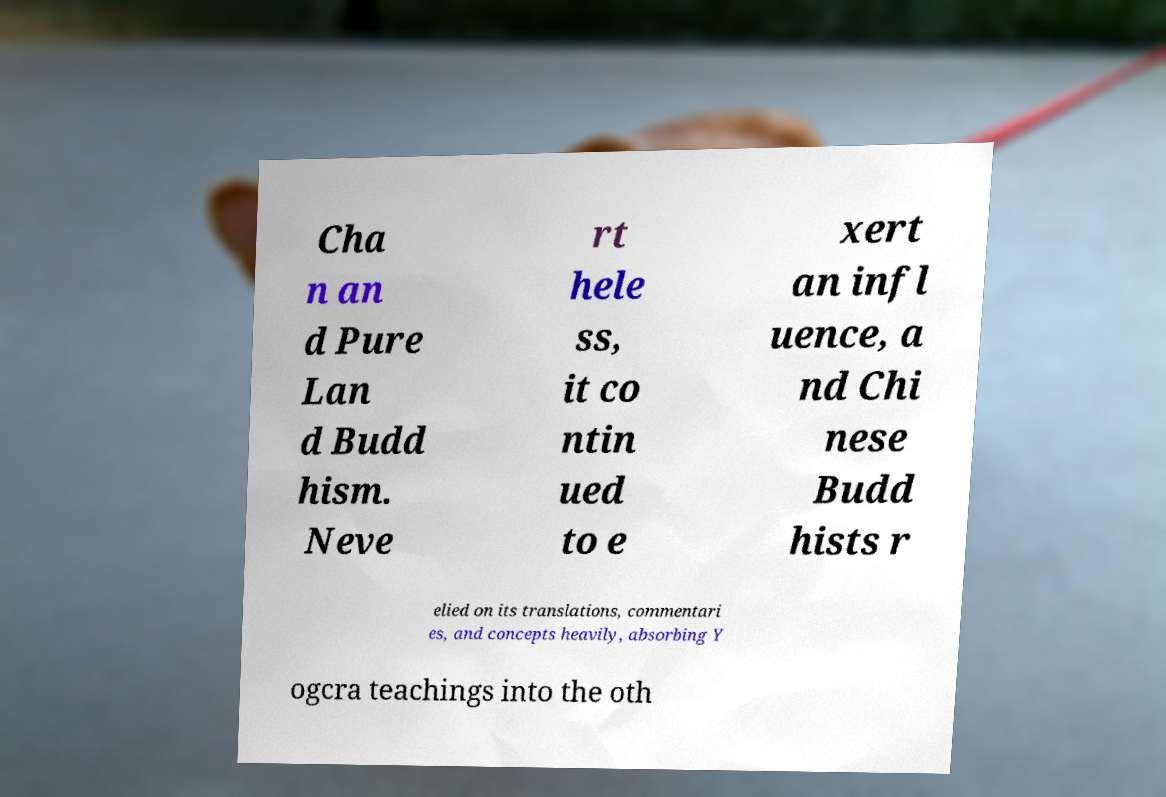Can you read and provide the text displayed in the image?This photo seems to have some interesting text. Can you extract and type it out for me? Cha n an d Pure Lan d Budd hism. Neve rt hele ss, it co ntin ued to e xert an infl uence, a nd Chi nese Budd hists r elied on its translations, commentari es, and concepts heavily, absorbing Y ogcra teachings into the oth 